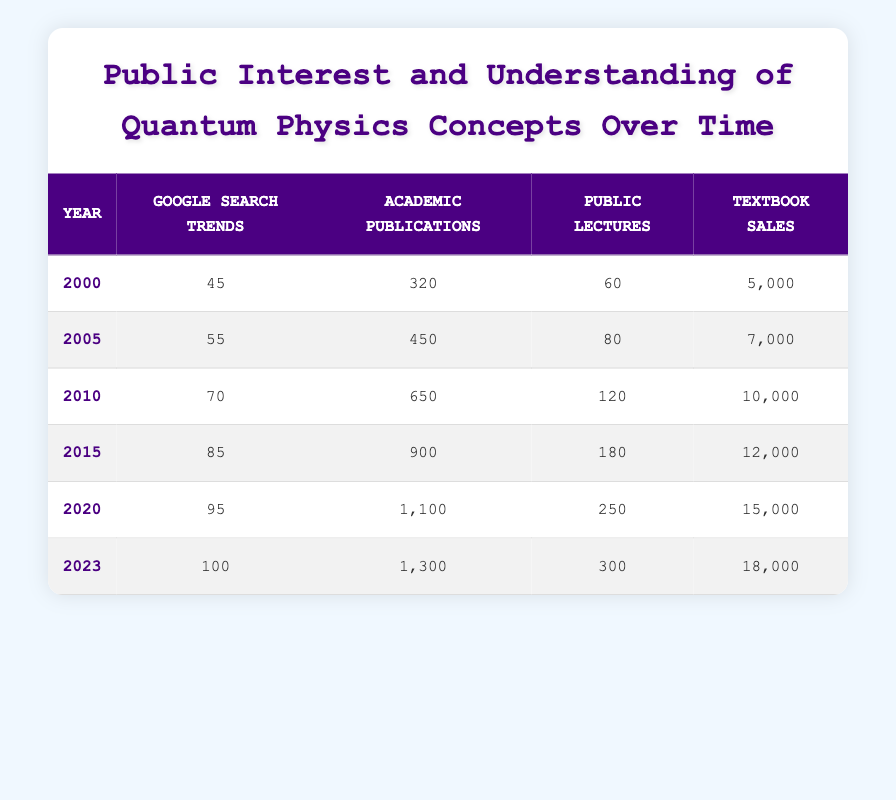What was the Google Search Trends value in 2015? In the table, for the year 2015, the Google Search Trends value is listed under that year’s data row. The value is 85.
Answer: 85 How many Public Lectures were held in 2000 compared to 2020? From the table, the number of Public Lectures in 2000 is 60, while in 2020 it is 250. To find the difference, we subtract: 250 - 60 = 190.
Answer: 190 What was the increase in Academic Publications from 2010 to 2023? The number of Academic Publications in 2010 is 650, and in 2023 it is 1300. To calculate the increase, we find the difference: 1300 - 650 = 650.
Answer: 650 Is the number of Textbook Sales in 2023 higher than in 2010? In 2023, the Textbook Sales figure is 18,000, while in 2010 it is 10,000. Since 18,000 is greater than 10,000, the statement is true.
Answer: Yes What is the average number of Public Lectures from 2000 to 2023? To find the average, first sum the total number of Public Lectures from each year: 60 + 80 + 120 + 180 + 250 + 300 = 990. Then divide by the number of years (6): 990 / 6 = 165.
Answer: 165 Which year had the highest Google Search Trends and what was that value? By observing the table, 2023 has the highest Google Search Trends value listed as 100.
Answer: 100 What was the total increase in Textbook Sales from 2000 to 2023? The total sales in 2000 were 5,000, and in 2023 they were 18,000. The total increase is calculated as follows: 18,000 - 5,000 = 13,000.
Answer: 13,000 How many more Academic Publications were there in 2020 compared to 2005? For 2020, the number of Academic Publications is 1,100, and for 2005, it is 450. The difference is: 1,100 - 450 = 650.
Answer: 650 In which year did Public Lectures first exceed 100? By examining the table, Public Lectures exceed 100 for the first time in the year 2010, when there were 120 Public Lectures.
Answer: 2010 What was the cumulative number of Google Search Trends over the entire period from 2000 to 2023? Summing the values of Google Search Trends for all years gives: 45 + 55 + 70 + 85 + 95 + 100 = 450.
Answer: 450 